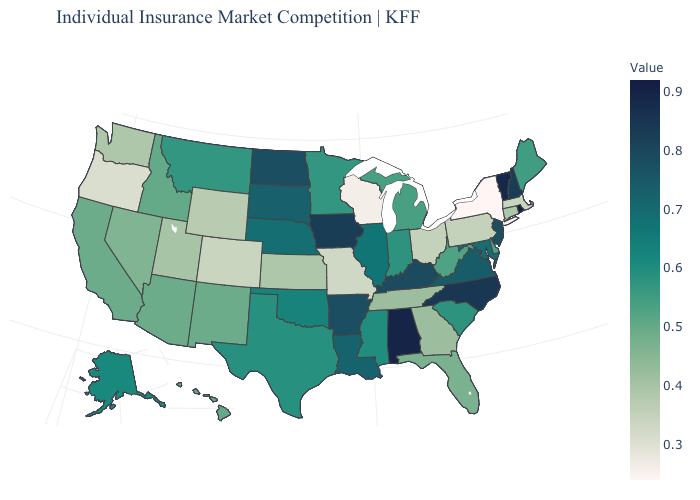Is the legend a continuous bar?
Keep it brief. Yes. Which states hav the highest value in the South?
Keep it brief. Alabama. Does Florida have the lowest value in the USA?
Concise answer only. No. Which states have the highest value in the USA?
Short answer required. Rhode Island. Among the states that border Massachusetts , which have the lowest value?
Keep it brief. New York. Does Alaska have the lowest value in the USA?
Give a very brief answer. No. Does Oregon have the lowest value in the West?
Give a very brief answer. Yes. Which states have the highest value in the USA?
Quick response, please. Rhode Island. 